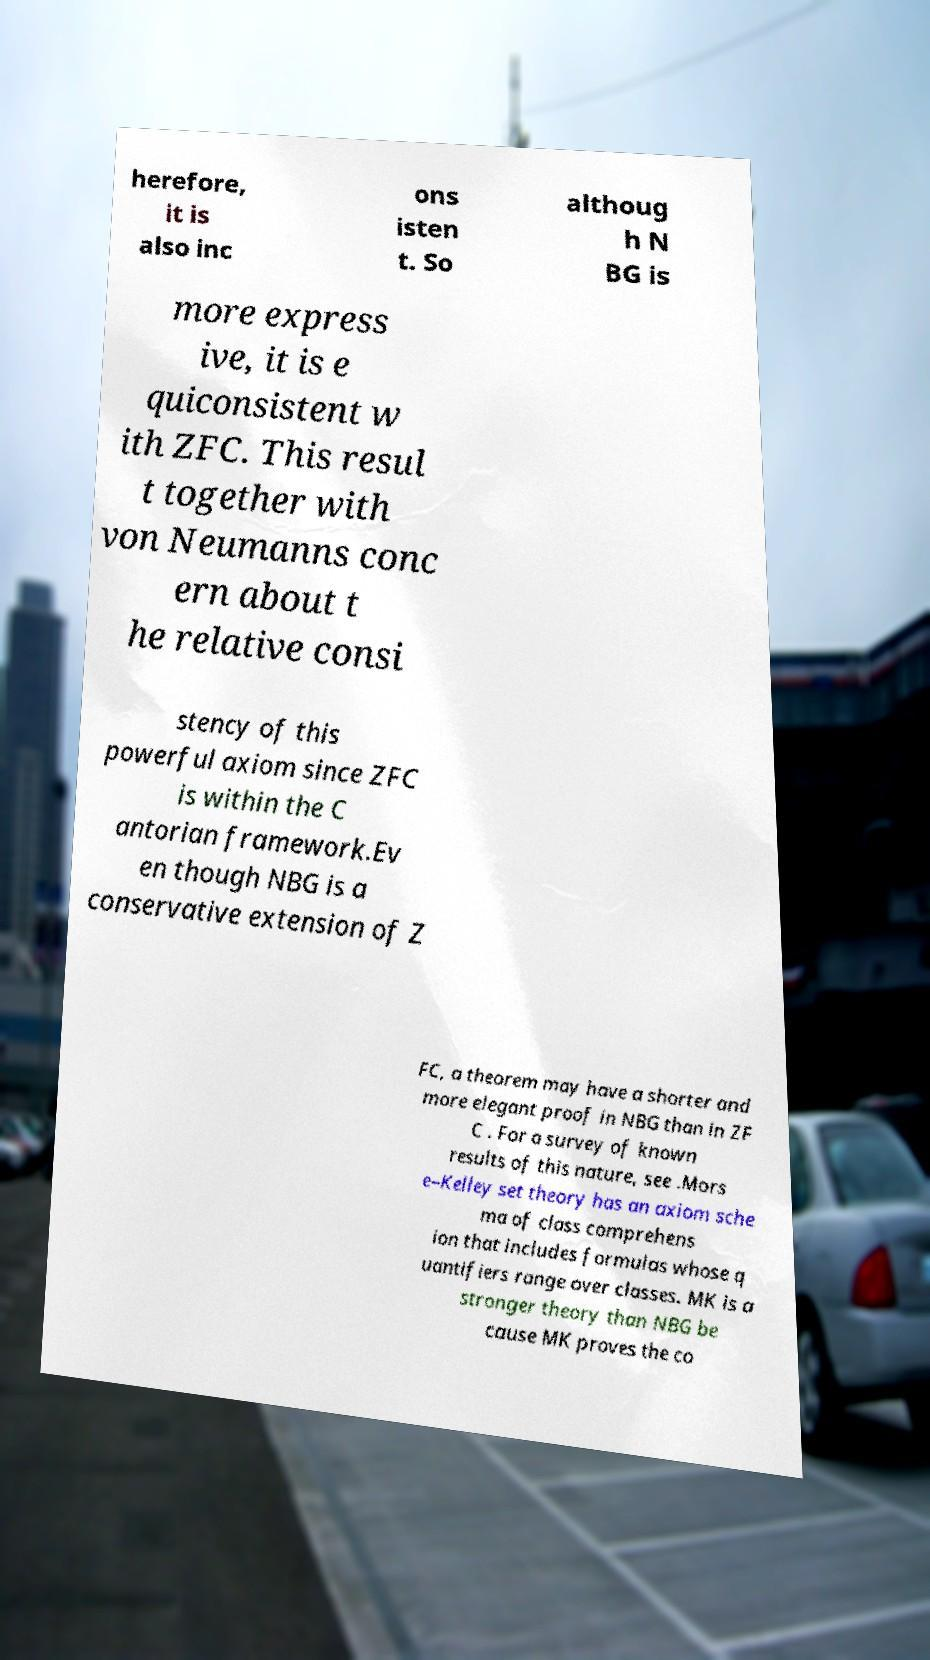What messages or text are displayed in this image? I need them in a readable, typed format. herefore, it is also inc ons isten t. So althoug h N BG is more express ive, it is e quiconsistent w ith ZFC. This resul t together with von Neumanns conc ern about t he relative consi stency of this powerful axiom since ZFC is within the C antorian framework.Ev en though NBG is a conservative extension of Z FC, a theorem may have a shorter and more elegant proof in NBG than in ZF C . For a survey of known results of this nature, see .Mors e–Kelley set theory has an axiom sche ma of class comprehens ion that includes formulas whose q uantifiers range over classes. MK is a stronger theory than NBG be cause MK proves the co 